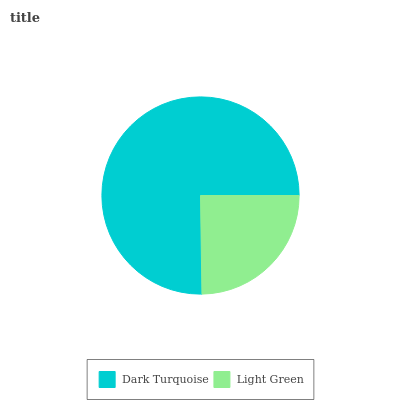Is Light Green the minimum?
Answer yes or no. Yes. Is Dark Turquoise the maximum?
Answer yes or no. Yes. Is Light Green the maximum?
Answer yes or no. No. Is Dark Turquoise greater than Light Green?
Answer yes or no. Yes. Is Light Green less than Dark Turquoise?
Answer yes or no. Yes. Is Light Green greater than Dark Turquoise?
Answer yes or no. No. Is Dark Turquoise less than Light Green?
Answer yes or no. No. Is Dark Turquoise the high median?
Answer yes or no. Yes. Is Light Green the low median?
Answer yes or no. Yes. Is Light Green the high median?
Answer yes or no. No. Is Dark Turquoise the low median?
Answer yes or no. No. 